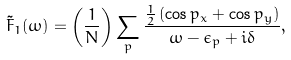<formula> <loc_0><loc_0><loc_500><loc_500>\tilde { F } _ { 1 } ( \omega ) = \left ( \frac { 1 } { N } \right ) \sum _ { p } \frac { \frac { 1 } { 2 } \left ( \cos p _ { x } + \cos p _ { y } \right ) } { \omega - \epsilon _ { p } + i \delta } ,</formula> 